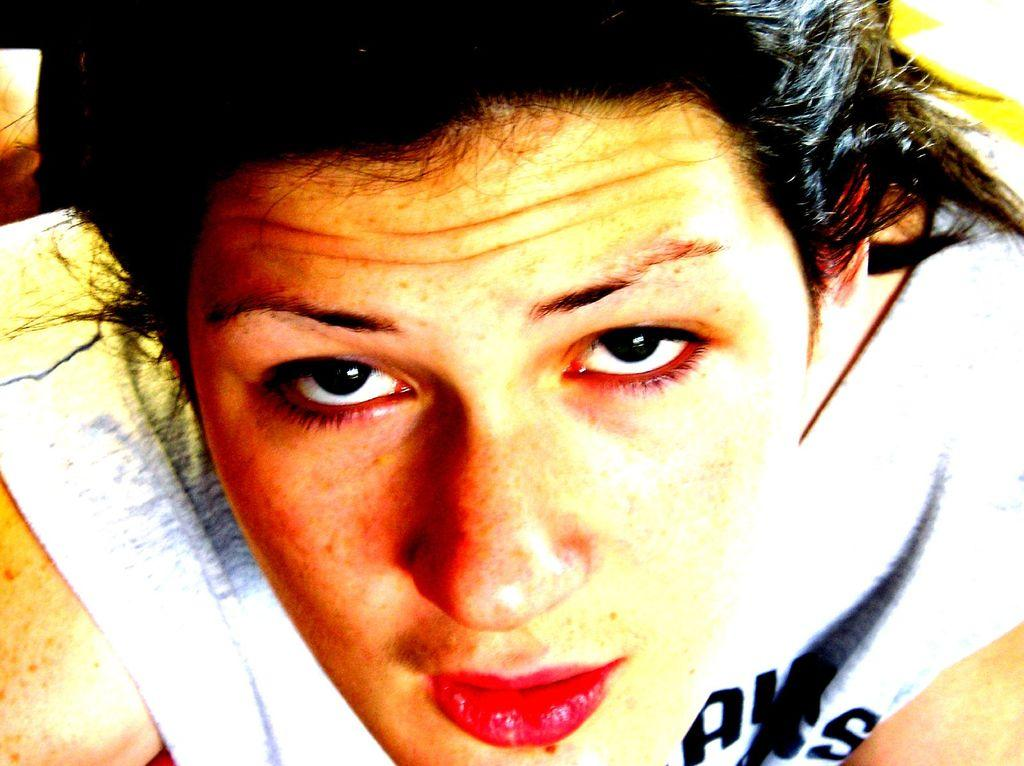What is the main subject in the image? There is a person in the image. How many cubs can be seen playing in the hall in the image? There are no cubs or halls present in the image; it features a person. 